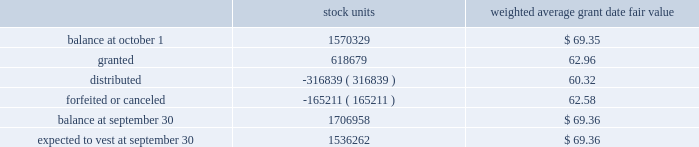The weighted average grant date fair value of performance-based restricted stock units granted during the years 2008 and 2007 was $ 84.33 and $ 71.72 , respectively .
The total fair value of performance-based restricted stock units vested during 2009 , 2008 and 2007 was $ 33712 , $ 49387 and $ 9181 , respectively .
At september 30 , 2009 , the weighted average remaining vesting term of performance-based restricted stock units is 1.28 years .
Time-vested restricted stock units time-vested restricted stock units generally cliff vest three years after the date of grant , except for certain key executives of the company , including the executive officers , for which such units generally vest one year following the employee 2019s retirement .
The related share-based compensation expense is recorded over the requisite service period , which is the vesting period or in the case of certain key executives is based on retirement eligibility .
The fair value of all time-vested restricted stock units is based on the market value of the company 2019s stock on the date of grant .
A summary of time-vested restricted stock units outstanding as of september 30 , 2009 , and changes during the year then ended is as follows : weighted average grant date fair value .
The weighted average grant date fair value of time-vested restricted stock units granted during the years 2008 and 2007 was $ 84.42 and $ 72.20 , respectively .
The total fair value of time-vested restricted stock units vested during 2009 , 2008 and 2007 was $ 29535 , $ 26674 and $ 3392 , respectively .
At september 30 , 2009 , the weighted average remaining vesting term of the time-vested restricted stock units is 1.71 years .
The amount of unrecognized compensation expense for all non-vested share-based awards as of september 30 , 2009 , is approximately $ 97034 , which is expected to be recognized over a weighted-average remaining life of approximately 2.02 years .
At september 30 , 2009 , 4295402 shares were authorized for future grants under the 2004 plan .
The company has a policy of satisfying share-based payments through either open market purchases or shares held in treasury .
At september 30 , 2009 , the company has sufficient shares held in treasury to satisfy these payments in 2010 .
Other stock plans the company has a stock award plan , which allows for grants of common shares to certain key employees .
Distribution of 25% ( 25 % ) or more of each award is deferred until after retirement or involuntary termination , upon which the deferred portion of the award is distributable in five equal annual installments .
The balance of the award is distributable over five years from the grant date , subject to certain conditions .
In february 2004 , this plan was terminated with respect to future grants upon the adoption of the 2004 plan .
At september 30 , 2009 and 2008 , awards for 114197 and 161145 shares , respectively , were outstanding .
Becton , dickinson and company notes to consolidated financial statements 2014 ( continued ) .
In 2009 what was the ratio of the 3 granted to the sum of the distributed and forfeited or canceled shares? 
Computations: (618679 / (165211 + 316839))
Answer: 1.28343. The weighted average grant date fair value of performance-based restricted stock units granted during the years 2008 and 2007 was $ 84.33 and $ 71.72 , respectively .
The total fair value of performance-based restricted stock units vested during 2009 , 2008 and 2007 was $ 33712 , $ 49387 and $ 9181 , respectively .
At september 30 , 2009 , the weighted average remaining vesting term of performance-based restricted stock units is 1.28 years .
Time-vested restricted stock units time-vested restricted stock units generally cliff vest three years after the date of grant , except for certain key executives of the company , including the executive officers , for which such units generally vest one year following the employee 2019s retirement .
The related share-based compensation expense is recorded over the requisite service period , which is the vesting period or in the case of certain key executives is based on retirement eligibility .
The fair value of all time-vested restricted stock units is based on the market value of the company 2019s stock on the date of grant .
A summary of time-vested restricted stock units outstanding as of september 30 , 2009 , and changes during the year then ended is as follows : weighted average grant date fair value .
The weighted average grant date fair value of time-vested restricted stock units granted during the years 2008 and 2007 was $ 84.42 and $ 72.20 , respectively .
The total fair value of time-vested restricted stock units vested during 2009 , 2008 and 2007 was $ 29535 , $ 26674 and $ 3392 , respectively .
At september 30 , 2009 , the weighted average remaining vesting term of the time-vested restricted stock units is 1.71 years .
The amount of unrecognized compensation expense for all non-vested share-based awards as of september 30 , 2009 , is approximately $ 97034 , which is expected to be recognized over a weighted-average remaining life of approximately 2.02 years .
At september 30 , 2009 , 4295402 shares were authorized for future grants under the 2004 plan .
The company has a policy of satisfying share-based payments through either open market purchases or shares held in treasury .
At september 30 , 2009 , the company has sufficient shares held in treasury to satisfy these payments in 2010 .
Other stock plans the company has a stock award plan , which allows for grants of common shares to certain key employees .
Distribution of 25% ( 25 % ) or more of each award is deferred until after retirement or involuntary termination , upon which the deferred portion of the award is distributable in five equal annual installments .
The balance of the award is distributable over five years from the grant date , subject to certain conditions .
In february 2004 , this plan was terminated with respect to future grants upon the adoption of the 2004 plan .
At september 30 , 2009 and 2008 , awards for 114197 and 161145 shares , respectively , were outstanding .
Becton , dickinson and company notes to consolidated financial statements 2014 ( continued ) .
What is the average of total fair value of time-vested restricted stock units vested during 2009 , 2008 and 2007? 
Computations: (((29535 + 26674) + 3392) / 3)
Answer: 19867.0. 